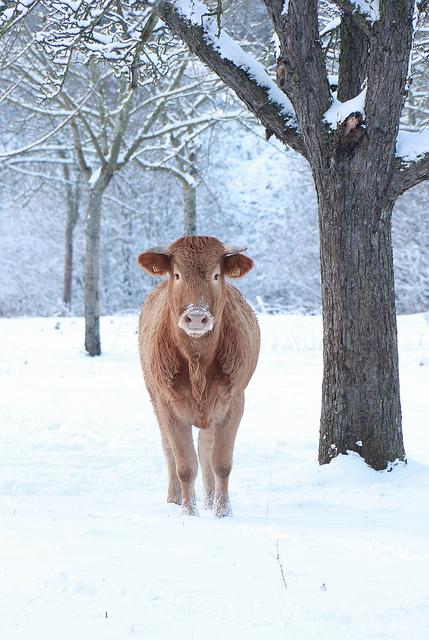Is the snow deep?
Quick response, please. No. Is the cow looking toward the camera?
Quick response, please. Yes. Is it a sunny day?
Be succinct. No. 